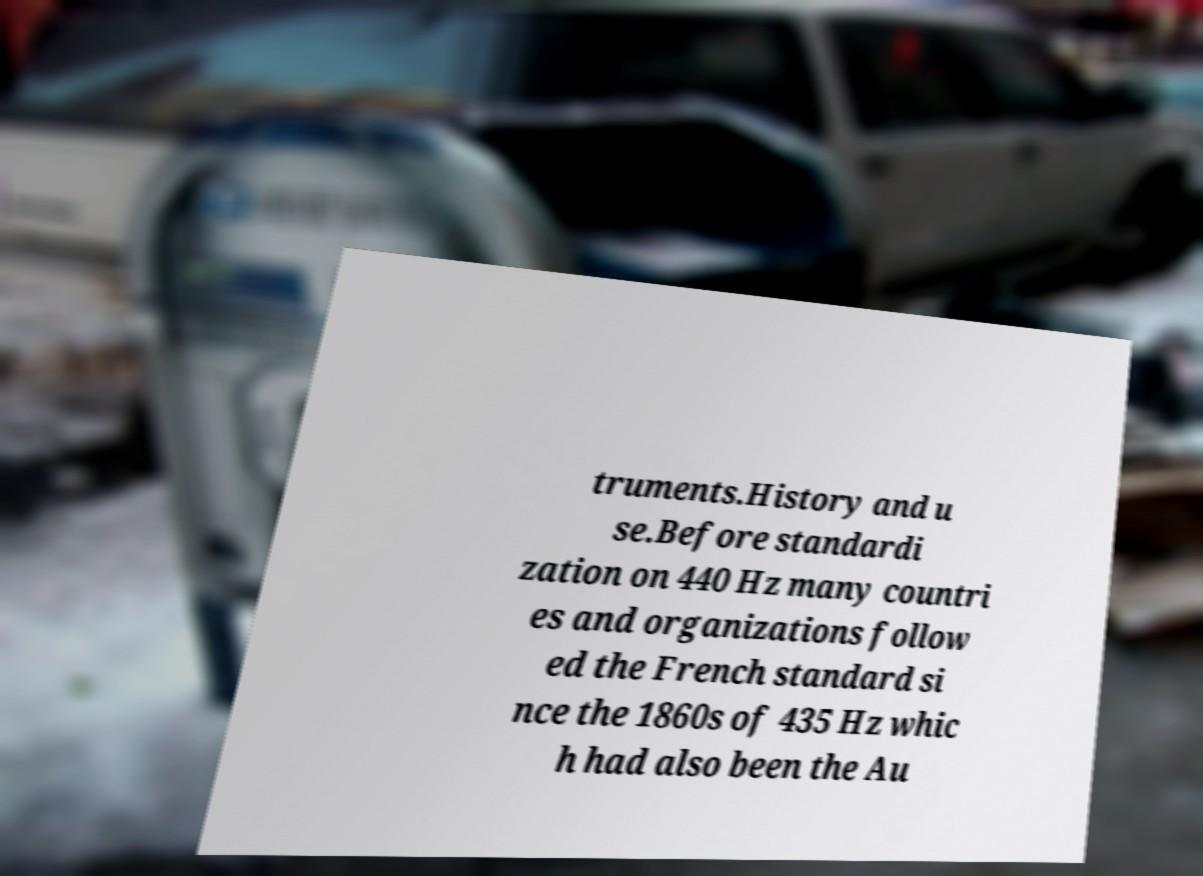Please read and relay the text visible in this image. What does it say? truments.History and u se.Before standardi zation on 440 Hz many countri es and organizations follow ed the French standard si nce the 1860s of 435 Hz whic h had also been the Au 